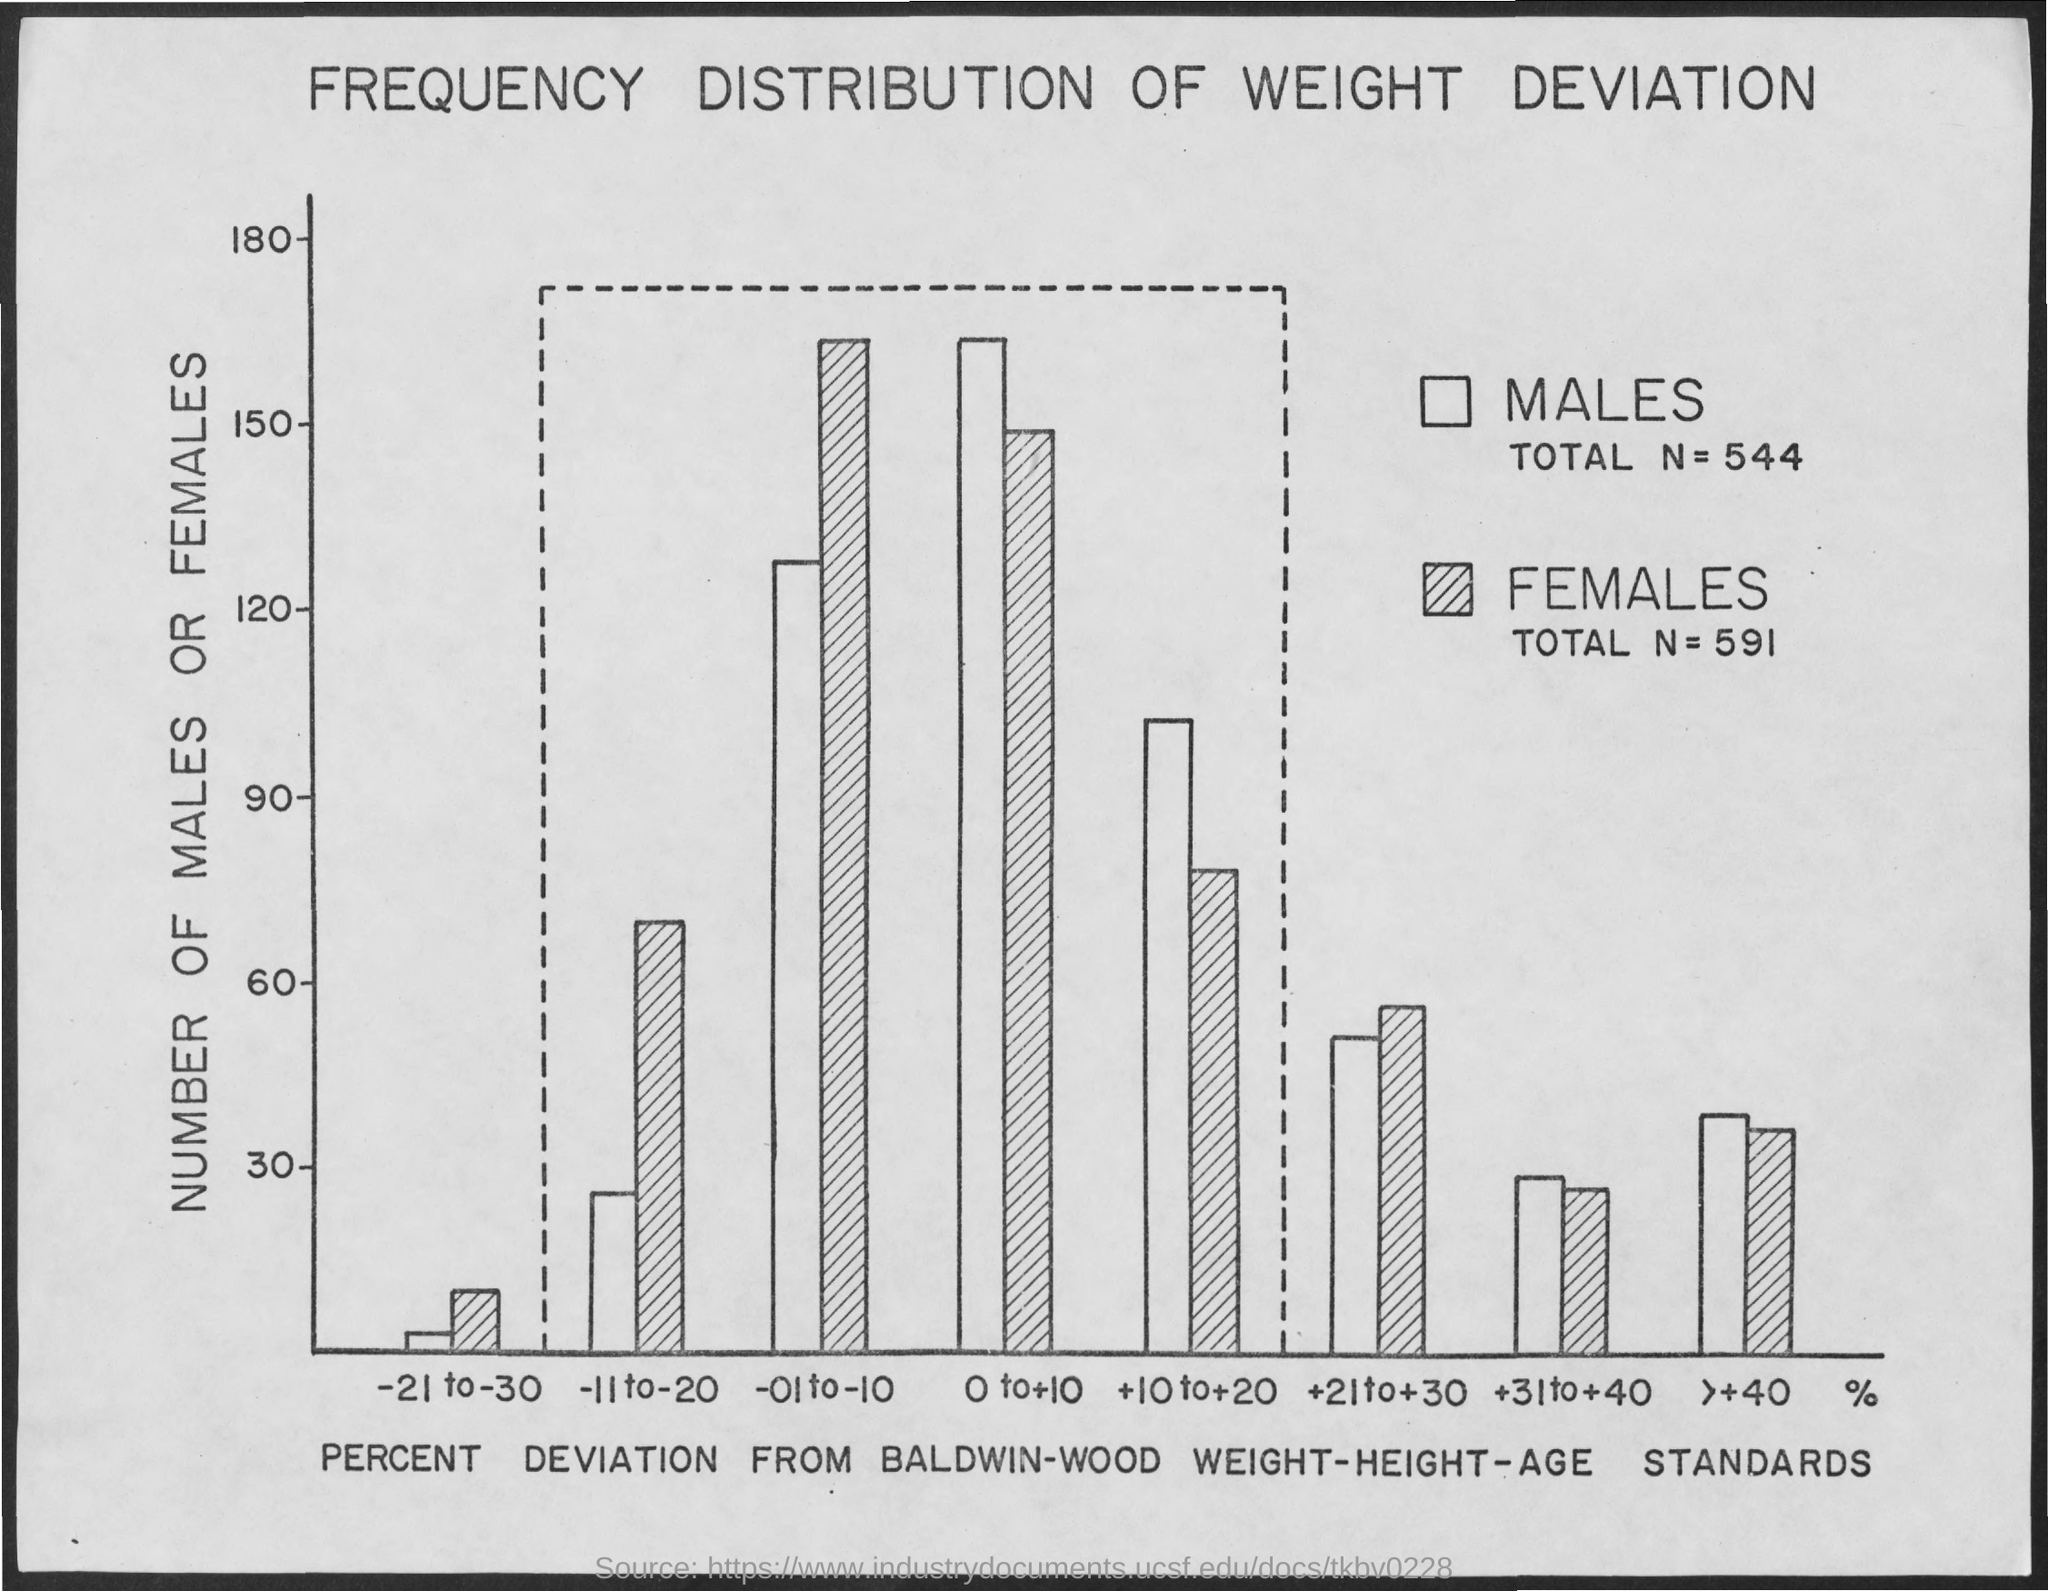Draw attention to some important aspects in this diagram. The x-axis of the graph represents the percent deviation from the Baldwin-Wood weight-height-age standards. The total number of females is 591. The total number of males is 544. The title of the graph shown is "Frequency Distribution of Weight Deviation. The y-axis of the graph represents the number of males or females. 